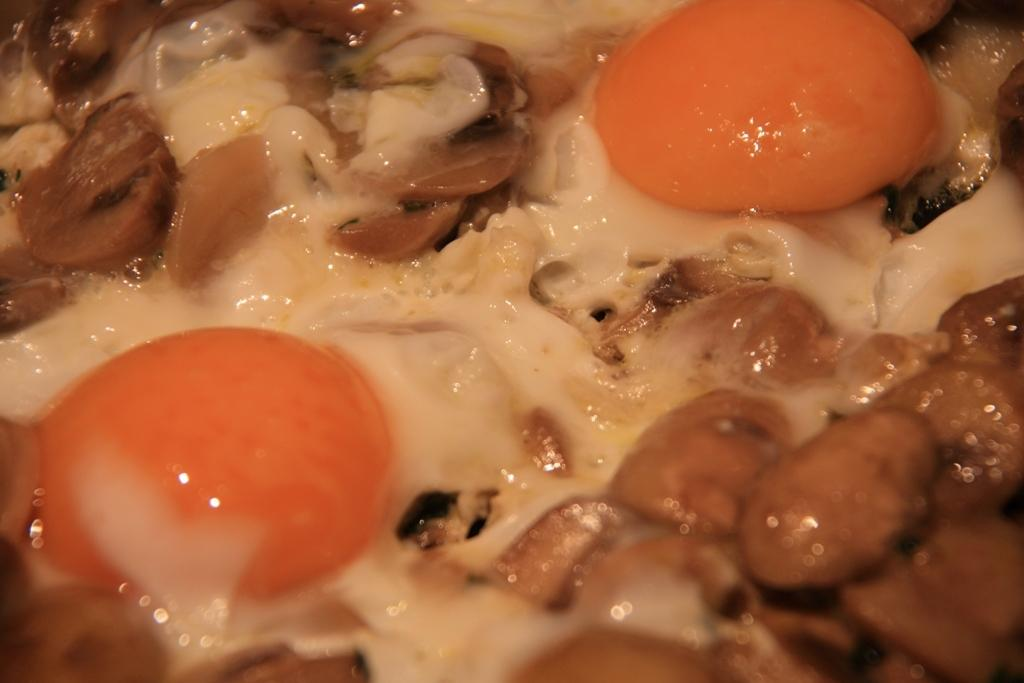What is the main subject of the image? The main subject of the image is a zoomed in picture of a food item. What ingredient can be found in the food item? The food item contains eggs. What is the purpose of the story being told by the food item in the image? There is no story being told by the food item in the image, as it is a static picture of a food item containing eggs. 